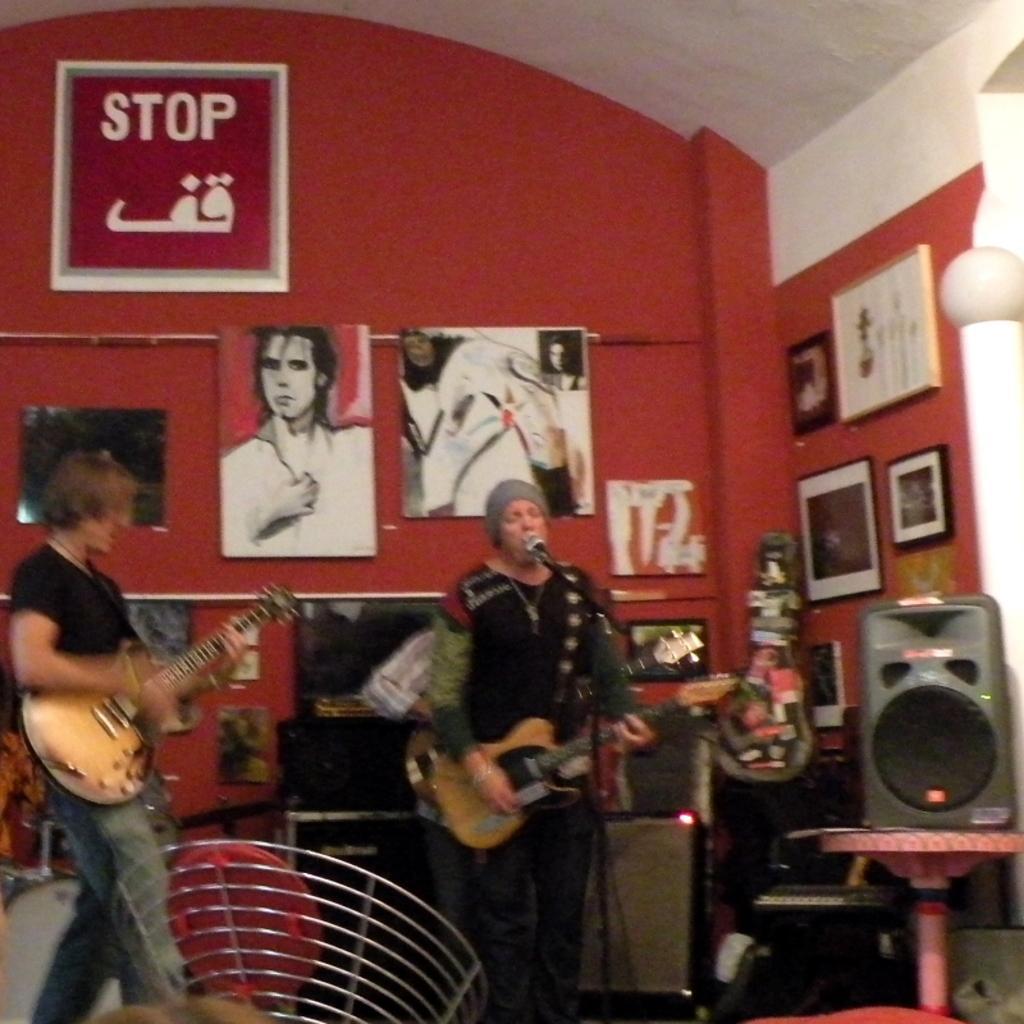Please provide a concise description of this image. In this picture there is a man who is standing in the center of the image, by holding a guitar in his hands and there is a mic in front of him and there is another man, by holding the guitar on the left side of the image and there are posters on the wall and there is a speaker on the right side of the image. 